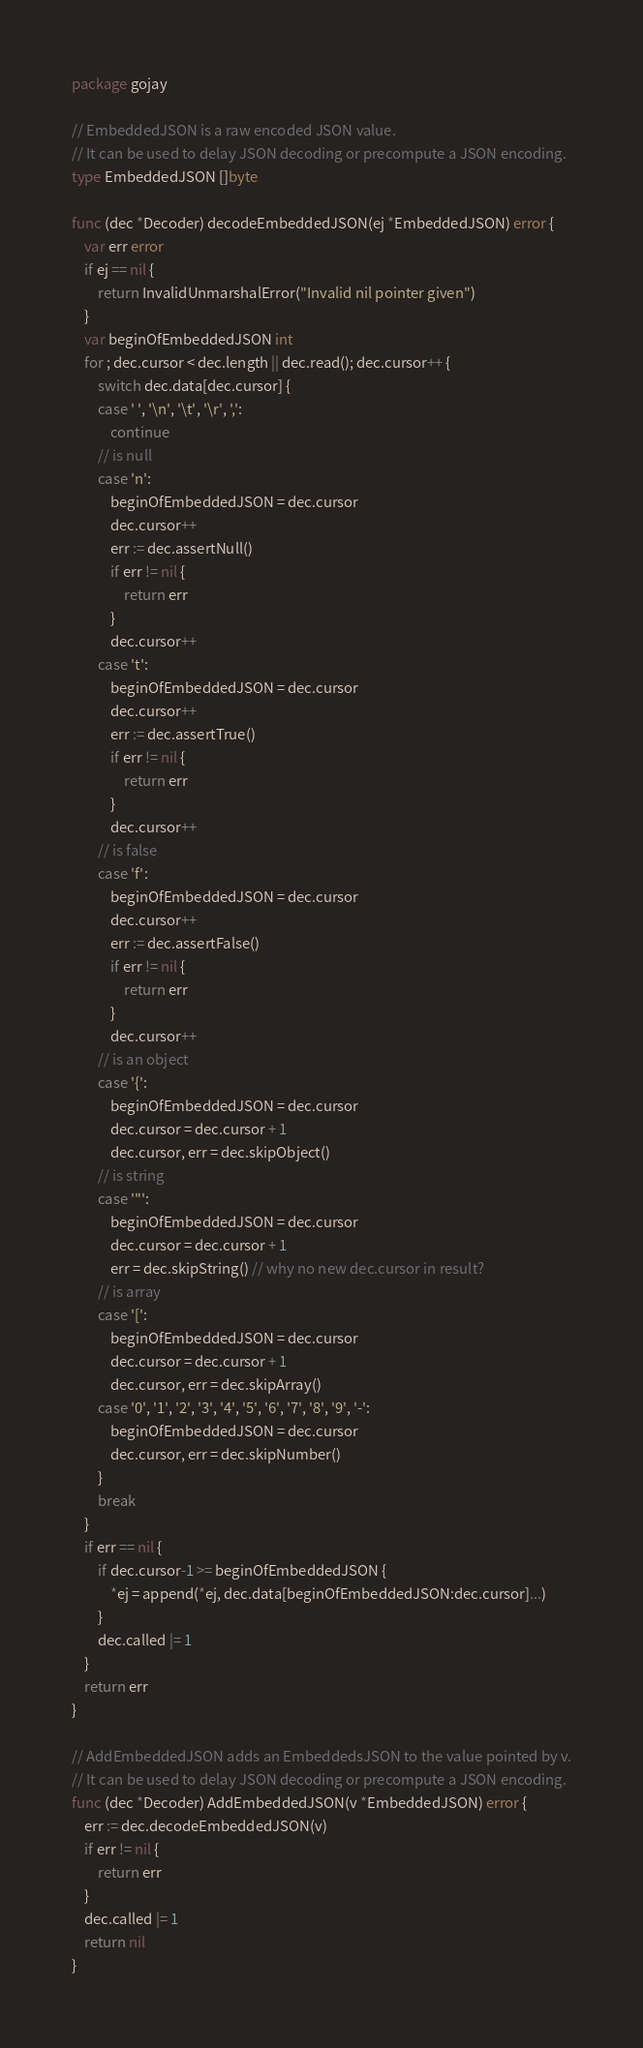<code> <loc_0><loc_0><loc_500><loc_500><_Go_>package gojay

// EmbeddedJSON is a raw encoded JSON value.
// It can be used to delay JSON decoding or precompute a JSON encoding.
type EmbeddedJSON []byte

func (dec *Decoder) decodeEmbeddedJSON(ej *EmbeddedJSON) error {
	var err error
	if ej == nil {
		return InvalidUnmarshalError("Invalid nil pointer given")
	}
	var beginOfEmbeddedJSON int
	for ; dec.cursor < dec.length || dec.read(); dec.cursor++ {
		switch dec.data[dec.cursor] {
		case ' ', '\n', '\t', '\r', ',':
			continue
		// is null
		case 'n':
			beginOfEmbeddedJSON = dec.cursor
			dec.cursor++
			err := dec.assertNull()
			if err != nil {
				return err
			}
			dec.cursor++
		case 't':
			beginOfEmbeddedJSON = dec.cursor
			dec.cursor++
			err := dec.assertTrue()
			if err != nil {
				return err
			}
			dec.cursor++
		// is false
		case 'f':
			beginOfEmbeddedJSON = dec.cursor
			dec.cursor++
			err := dec.assertFalse()
			if err != nil {
				return err
			}
			dec.cursor++
		// is an object
		case '{':
			beginOfEmbeddedJSON = dec.cursor
			dec.cursor = dec.cursor + 1
			dec.cursor, err = dec.skipObject()
		// is string
		case '"':
			beginOfEmbeddedJSON = dec.cursor
			dec.cursor = dec.cursor + 1
			err = dec.skipString() // why no new dec.cursor in result?
		// is array
		case '[':
			beginOfEmbeddedJSON = dec.cursor
			dec.cursor = dec.cursor + 1
			dec.cursor, err = dec.skipArray()
		case '0', '1', '2', '3', '4', '5', '6', '7', '8', '9', '-':
			beginOfEmbeddedJSON = dec.cursor
			dec.cursor, err = dec.skipNumber()
		}
		break
	}
	if err == nil {
		if dec.cursor-1 >= beginOfEmbeddedJSON {
			*ej = append(*ej, dec.data[beginOfEmbeddedJSON:dec.cursor]...)
		}
		dec.called |= 1
	}
	return err
}

// AddEmbeddedJSON adds an EmbeddedsJSON to the value pointed by v.
// It can be used to delay JSON decoding or precompute a JSON encoding.
func (dec *Decoder) AddEmbeddedJSON(v *EmbeddedJSON) error {
	err := dec.decodeEmbeddedJSON(v)
	if err != nil {
		return err
	}
	dec.called |= 1
	return nil
}
</code> 